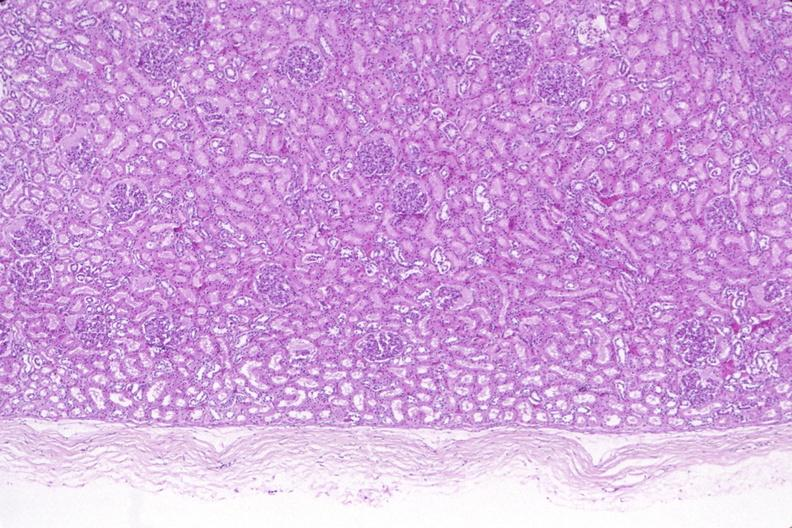does anencephaly and bilateral cleft palate show kidney, normal histology?
Answer the question using a single word or phrase. No 